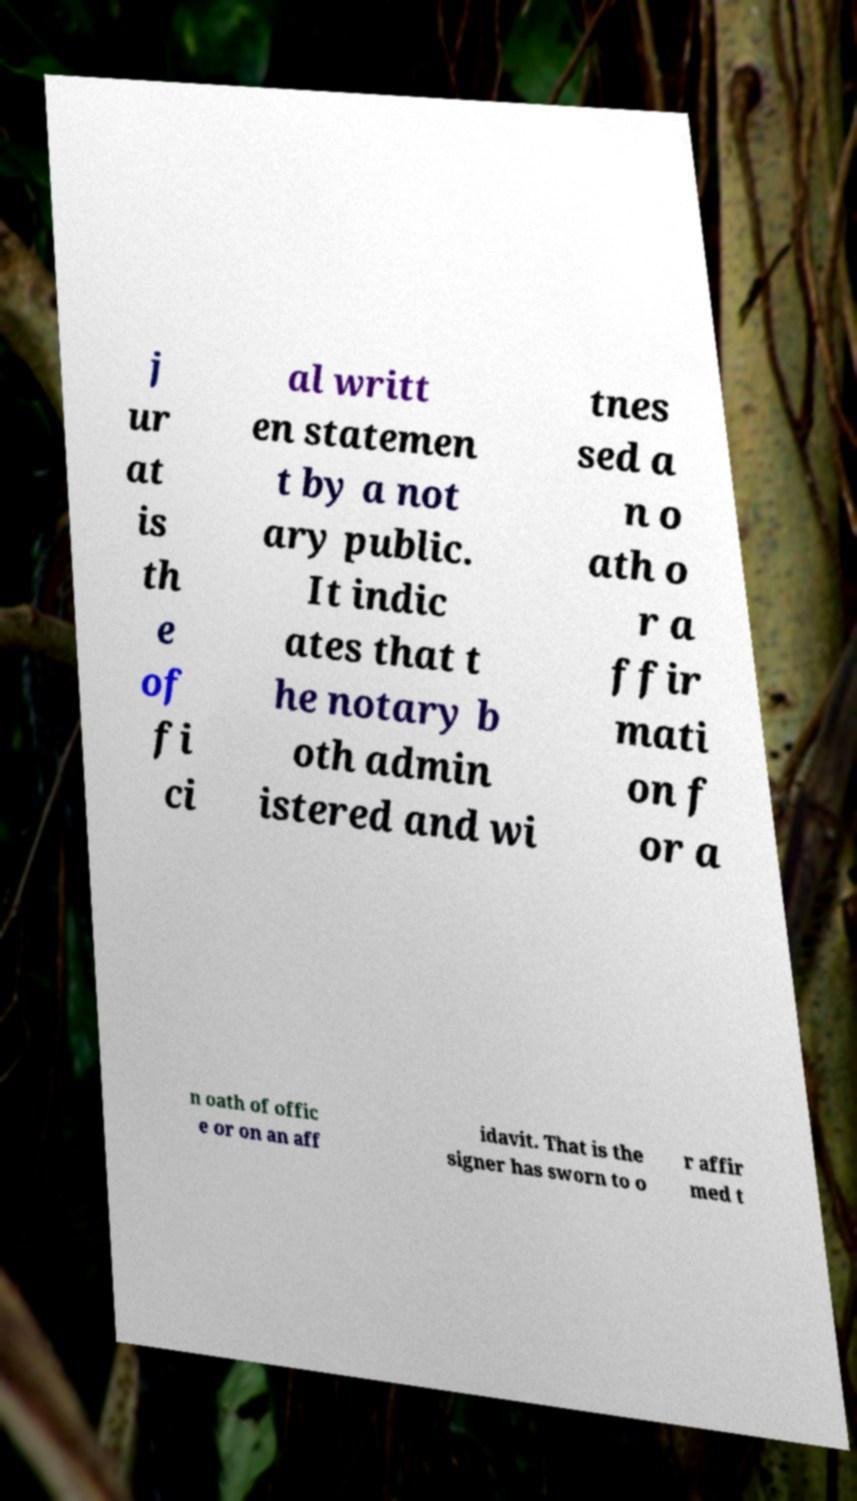For documentation purposes, I need the text within this image transcribed. Could you provide that? j ur at is th e of fi ci al writt en statemen t by a not ary public. It indic ates that t he notary b oth admin istered and wi tnes sed a n o ath o r a ffir mati on f or a n oath of offic e or on an aff idavit. That is the signer has sworn to o r affir med t 